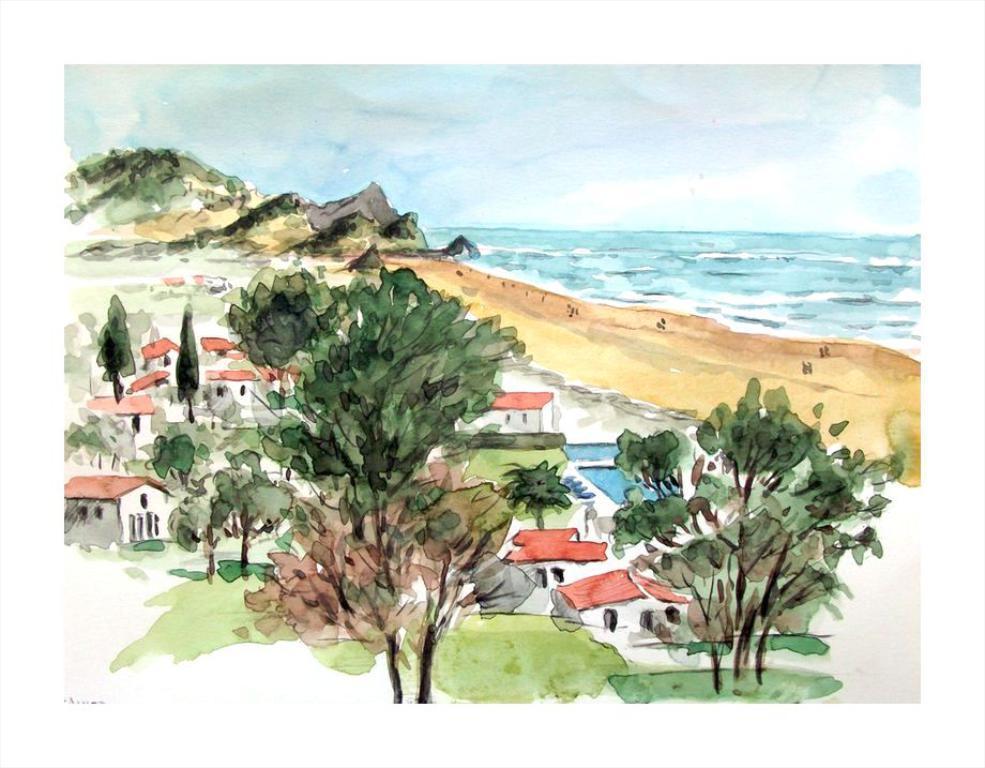Describe this image in one or two sentences. In this image we can see the painting of houses and trees. Here we can see the painting of an ocean on the right side. Here we can see the mountains on the left side. This is a sky with clouds. 